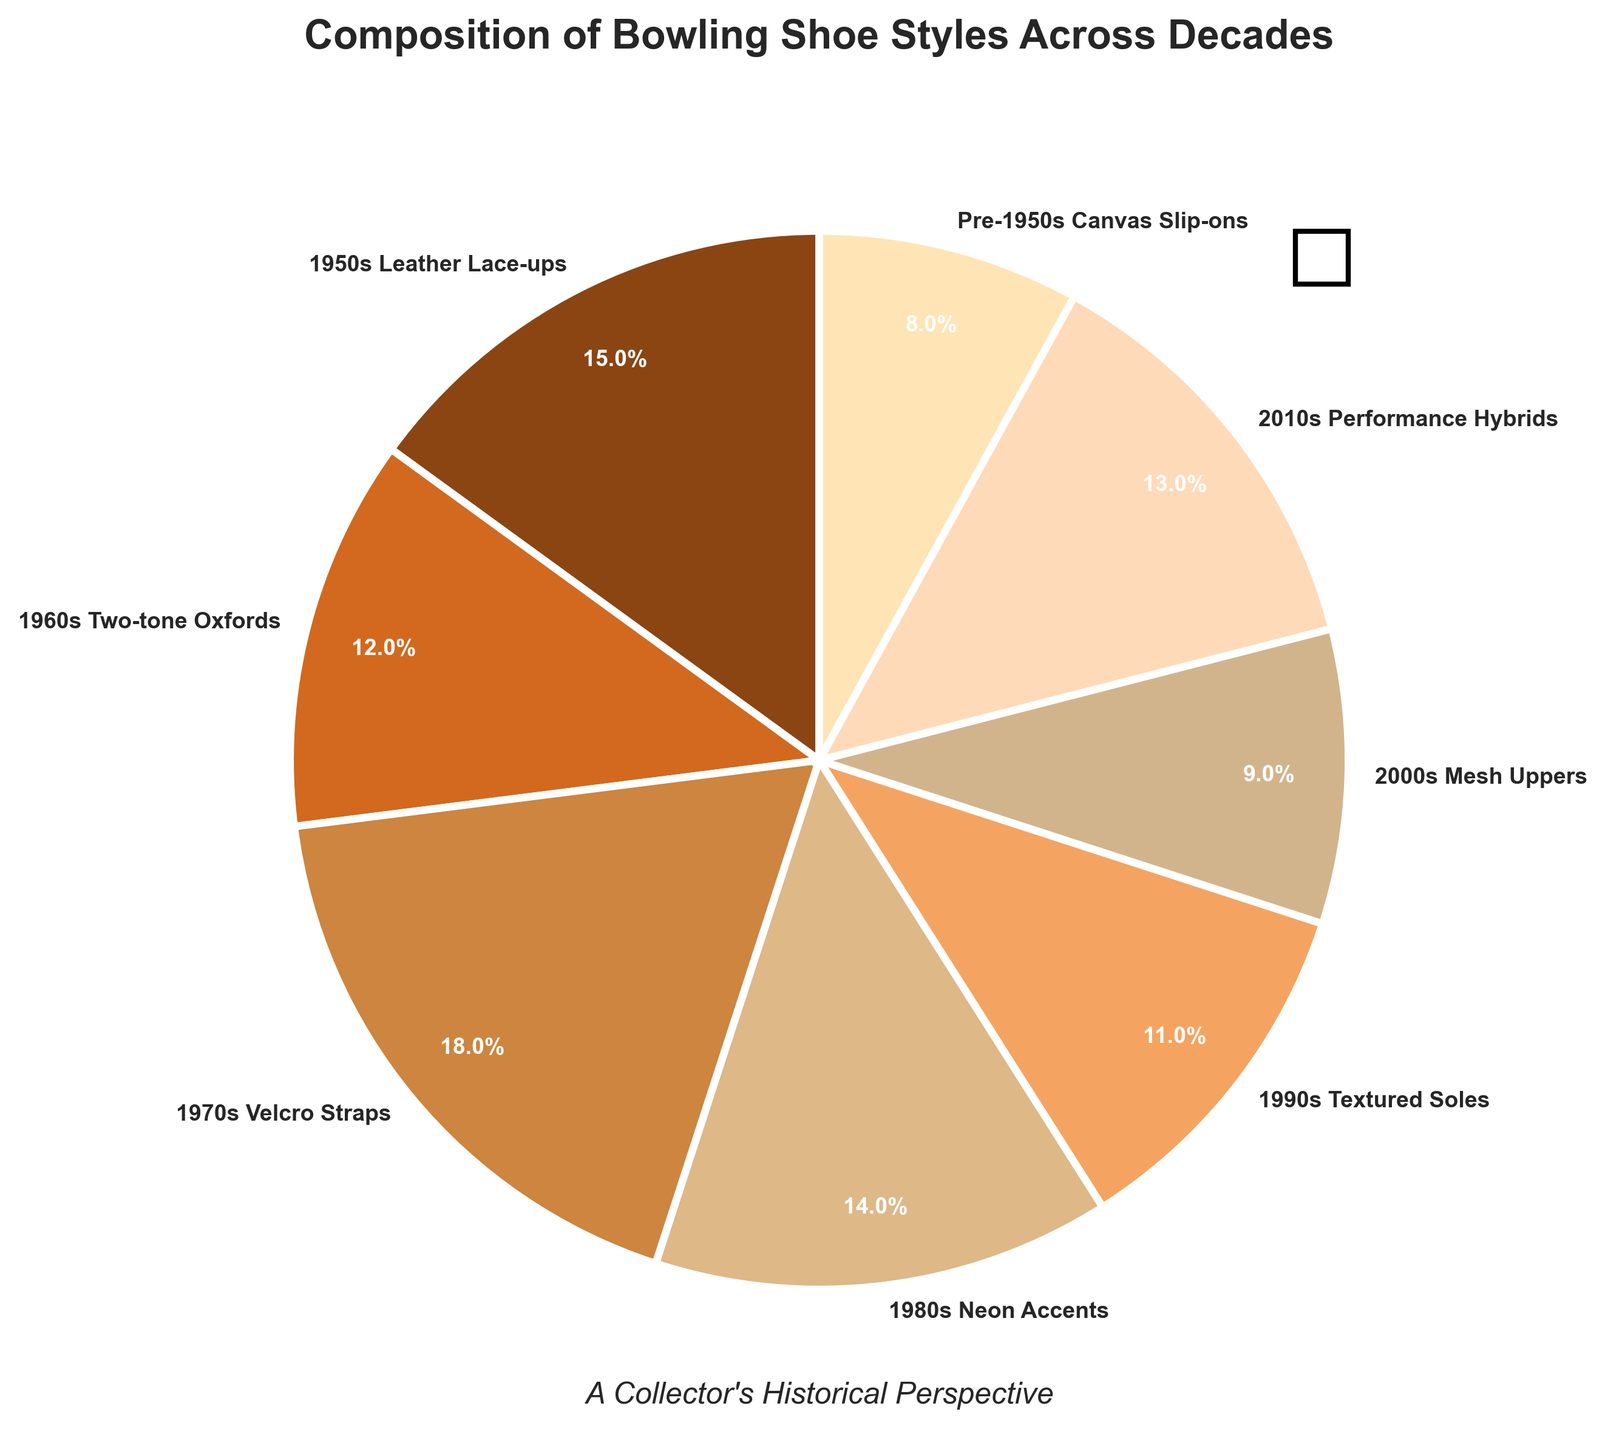What is the most common style of bowling shoe across the decades? The wedges in the pie chart show percentage data labeled by each decade. The largest segment corresponds to the 1970s Velcro Straps at 18%.
Answer: 1970s Velcro Straps Which two decades contributed equally to the collection of bowling shoes? The slices of the pie chart represent each decade with labeled percentages. Both the 1960s Two-tone Oxfords and the 2010s Performance Hybrids show a percentage of 13%.
Answer: 1960s Two-tone Oxfords and 2010s Performance Hybrids How many percentage points higher is the contribution of the 1950s Leather Lace-ups compared to the 2000s Mesh Uppers? The 1950s Leather Lace-ups slice is labeled 15% and the 2000s Mesh Uppers slice is labeled 9%. Subtracting these gives 15% - 9% = 6%.
Answer: 6% Summing the contributions, what is the combined percentage of the three least common styles? The pie chart shows the following least common styles: Pre-1950s Canvas Slip-ons (8%), 2000s Mesh Uppers (9%), and 1990s Textured Soles (11%). Summing them: (8 + 9 + 11) = 28%.
Answer: 28% Which three decades collectively make up more than half of the bowling shoe style collection? The pie chart shows the following percentages for each decade: 1970s Velcro Straps (18%), 1950s Leather Lace-ups (15%), and 1980s Neon Accents (14%). Summing them: (18 + 15 + 14) = 47%, which is less than half. Including the 2010s Performance Hybrids, the sum is (47 + 13) = 60%, which is more than half.
Answer: 1970s, 1950s, 1980s Which decade's bowling shoe style has the smallest contribution? The pie chart's smallest slice shows 8%, labeled as Pre-1950s Canvas Slip-ons
Answer: Pre-1950s Canvas Slip-ons Is the contribution of the 1960s Two-tone Oxfords greater than that of the 2010s Performance Hybrids? Both the 1960s Two-tone Oxfords and the 2010s Performance Hybrids have an equal contribution, each labeled at 13%.
Answer: No, it's equal What is the median percentage value considering all the decades? To find the median, first list the percentages in ascending order: 8%, 9%, 11%, 12%, 13%, 14%, 15%, 18%. The middle values are 12% and 13%. The median is their average: (12 + 13) / 2 = 12.5%.
Answer: 12.5% 